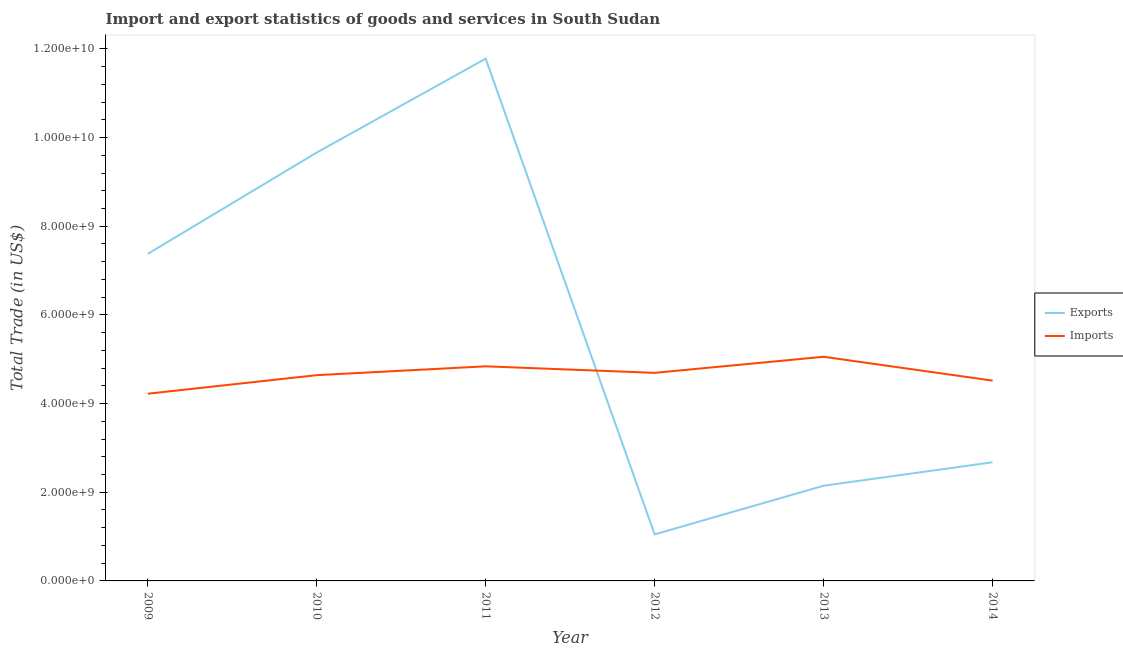Does the line corresponding to export of goods and services intersect with the line corresponding to imports of goods and services?
Give a very brief answer. Yes. What is the export of goods and services in 2010?
Your answer should be compact. 9.66e+09. Across all years, what is the maximum export of goods and services?
Your response must be concise. 1.18e+1. Across all years, what is the minimum imports of goods and services?
Your answer should be very brief. 4.22e+09. What is the total export of goods and services in the graph?
Offer a terse response. 3.47e+1. What is the difference between the export of goods and services in 2012 and that in 2013?
Offer a very short reply. -1.10e+09. What is the difference between the export of goods and services in 2012 and the imports of goods and services in 2014?
Keep it short and to the point. -3.47e+09. What is the average imports of goods and services per year?
Provide a succinct answer. 4.66e+09. In the year 2011, what is the difference between the imports of goods and services and export of goods and services?
Make the answer very short. -6.94e+09. In how many years, is the imports of goods and services greater than 5600000000 US$?
Your answer should be very brief. 0. What is the ratio of the imports of goods and services in 2009 to that in 2011?
Ensure brevity in your answer.  0.87. Is the difference between the export of goods and services in 2009 and 2012 greater than the difference between the imports of goods and services in 2009 and 2012?
Ensure brevity in your answer.  Yes. What is the difference between the highest and the second highest imports of goods and services?
Provide a succinct answer. 2.16e+08. What is the difference between the highest and the lowest imports of goods and services?
Keep it short and to the point. 8.33e+08. Is the sum of the imports of goods and services in 2009 and 2012 greater than the maximum export of goods and services across all years?
Make the answer very short. No. Does the imports of goods and services monotonically increase over the years?
Your answer should be very brief. No. Is the export of goods and services strictly greater than the imports of goods and services over the years?
Offer a very short reply. No. How many lines are there?
Provide a succinct answer. 2. What is the difference between two consecutive major ticks on the Y-axis?
Your response must be concise. 2.00e+09. Are the values on the major ticks of Y-axis written in scientific E-notation?
Give a very brief answer. Yes. Does the graph contain grids?
Provide a succinct answer. No. Where does the legend appear in the graph?
Keep it short and to the point. Center right. What is the title of the graph?
Make the answer very short. Import and export statistics of goods and services in South Sudan. What is the label or title of the Y-axis?
Offer a terse response. Total Trade (in US$). What is the Total Trade (in US$) of Exports in 2009?
Ensure brevity in your answer.  7.38e+09. What is the Total Trade (in US$) of Imports in 2009?
Make the answer very short. 4.22e+09. What is the Total Trade (in US$) in Exports in 2010?
Ensure brevity in your answer.  9.66e+09. What is the Total Trade (in US$) in Imports in 2010?
Your answer should be very brief. 4.64e+09. What is the Total Trade (in US$) in Exports in 2011?
Offer a very short reply. 1.18e+1. What is the Total Trade (in US$) in Imports in 2011?
Offer a terse response. 4.84e+09. What is the Total Trade (in US$) in Exports in 2012?
Give a very brief answer. 1.05e+09. What is the Total Trade (in US$) in Imports in 2012?
Offer a very short reply. 4.69e+09. What is the Total Trade (in US$) of Exports in 2013?
Ensure brevity in your answer.  2.15e+09. What is the Total Trade (in US$) of Imports in 2013?
Your answer should be very brief. 5.06e+09. What is the Total Trade (in US$) in Exports in 2014?
Your answer should be compact. 2.68e+09. What is the Total Trade (in US$) in Imports in 2014?
Keep it short and to the point. 4.52e+09. Across all years, what is the maximum Total Trade (in US$) of Exports?
Your answer should be compact. 1.18e+1. Across all years, what is the maximum Total Trade (in US$) of Imports?
Ensure brevity in your answer.  5.06e+09. Across all years, what is the minimum Total Trade (in US$) of Exports?
Offer a very short reply. 1.05e+09. Across all years, what is the minimum Total Trade (in US$) in Imports?
Your response must be concise. 4.22e+09. What is the total Total Trade (in US$) in Exports in the graph?
Make the answer very short. 3.47e+1. What is the total Total Trade (in US$) of Imports in the graph?
Provide a short and direct response. 2.80e+1. What is the difference between the Total Trade (in US$) of Exports in 2009 and that in 2010?
Your answer should be very brief. -2.28e+09. What is the difference between the Total Trade (in US$) in Imports in 2009 and that in 2010?
Provide a short and direct response. -4.19e+08. What is the difference between the Total Trade (in US$) in Exports in 2009 and that in 2011?
Your response must be concise. -4.40e+09. What is the difference between the Total Trade (in US$) in Imports in 2009 and that in 2011?
Give a very brief answer. -6.18e+08. What is the difference between the Total Trade (in US$) in Exports in 2009 and that in 2012?
Your response must be concise. 6.33e+09. What is the difference between the Total Trade (in US$) in Imports in 2009 and that in 2012?
Offer a terse response. -4.70e+08. What is the difference between the Total Trade (in US$) of Exports in 2009 and that in 2013?
Your response must be concise. 5.23e+09. What is the difference between the Total Trade (in US$) of Imports in 2009 and that in 2013?
Provide a succinct answer. -8.33e+08. What is the difference between the Total Trade (in US$) in Exports in 2009 and that in 2014?
Provide a short and direct response. 4.70e+09. What is the difference between the Total Trade (in US$) of Imports in 2009 and that in 2014?
Your answer should be very brief. -2.95e+08. What is the difference between the Total Trade (in US$) of Exports in 2010 and that in 2011?
Offer a terse response. -2.12e+09. What is the difference between the Total Trade (in US$) of Imports in 2010 and that in 2011?
Your answer should be very brief. -1.99e+08. What is the difference between the Total Trade (in US$) of Exports in 2010 and that in 2012?
Provide a succinct answer. 8.61e+09. What is the difference between the Total Trade (in US$) in Imports in 2010 and that in 2012?
Offer a very short reply. -5.19e+07. What is the difference between the Total Trade (in US$) in Exports in 2010 and that in 2013?
Ensure brevity in your answer.  7.51e+09. What is the difference between the Total Trade (in US$) in Imports in 2010 and that in 2013?
Provide a succinct answer. -4.15e+08. What is the difference between the Total Trade (in US$) of Exports in 2010 and that in 2014?
Make the answer very short. 6.99e+09. What is the difference between the Total Trade (in US$) of Imports in 2010 and that in 2014?
Give a very brief answer. 1.23e+08. What is the difference between the Total Trade (in US$) in Exports in 2011 and that in 2012?
Provide a short and direct response. 1.07e+1. What is the difference between the Total Trade (in US$) in Imports in 2011 and that in 2012?
Give a very brief answer. 1.47e+08. What is the difference between the Total Trade (in US$) in Exports in 2011 and that in 2013?
Ensure brevity in your answer.  9.63e+09. What is the difference between the Total Trade (in US$) of Imports in 2011 and that in 2013?
Keep it short and to the point. -2.16e+08. What is the difference between the Total Trade (in US$) in Exports in 2011 and that in 2014?
Offer a very short reply. 9.10e+09. What is the difference between the Total Trade (in US$) in Imports in 2011 and that in 2014?
Keep it short and to the point. 3.22e+08. What is the difference between the Total Trade (in US$) in Exports in 2012 and that in 2013?
Make the answer very short. -1.10e+09. What is the difference between the Total Trade (in US$) of Imports in 2012 and that in 2013?
Your answer should be very brief. -3.63e+08. What is the difference between the Total Trade (in US$) of Exports in 2012 and that in 2014?
Keep it short and to the point. -1.63e+09. What is the difference between the Total Trade (in US$) of Imports in 2012 and that in 2014?
Provide a succinct answer. 1.75e+08. What is the difference between the Total Trade (in US$) of Exports in 2013 and that in 2014?
Keep it short and to the point. -5.29e+08. What is the difference between the Total Trade (in US$) in Imports in 2013 and that in 2014?
Provide a short and direct response. 5.38e+08. What is the difference between the Total Trade (in US$) in Exports in 2009 and the Total Trade (in US$) in Imports in 2010?
Give a very brief answer. 2.74e+09. What is the difference between the Total Trade (in US$) in Exports in 2009 and the Total Trade (in US$) in Imports in 2011?
Make the answer very short. 2.54e+09. What is the difference between the Total Trade (in US$) of Exports in 2009 and the Total Trade (in US$) of Imports in 2012?
Make the answer very short. 2.68e+09. What is the difference between the Total Trade (in US$) of Exports in 2009 and the Total Trade (in US$) of Imports in 2013?
Offer a terse response. 2.32e+09. What is the difference between the Total Trade (in US$) of Exports in 2009 and the Total Trade (in US$) of Imports in 2014?
Offer a very short reply. 2.86e+09. What is the difference between the Total Trade (in US$) of Exports in 2010 and the Total Trade (in US$) of Imports in 2011?
Give a very brief answer. 4.82e+09. What is the difference between the Total Trade (in US$) in Exports in 2010 and the Total Trade (in US$) in Imports in 2012?
Make the answer very short. 4.97e+09. What is the difference between the Total Trade (in US$) of Exports in 2010 and the Total Trade (in US$) of Imports in 2013?
Your response must be concise. 4.61e+09. What is the difference between the Total Trade (in US$) in Exports in 2010 and the Total Trade (in US$) in Imports in 2014?
Offer a terse response. 5.14e+09. What is the difference between the Total Trade (in US$) of Exports in 2011 and the Total Trade (in US$) of Imports in 2012?
Your answer should be compact. 7.09e+09. What is the difference between the Total Trade (in US$) in Exports in 2011 and the Total Trade (in US$) in Imports in 2013?
Make the answer very short. 6.72e+09. What is the difference between the Total Trade (in US$) in Exports in 2011 and the Total Trade (in US$) in Imports in 2014?
Ensure brevity in your answer.  7.26e+09. What is the difference between the Total Trade (in US$) in Exports in 2012 and the Total Trade (in US$) in Imports in 2013?
Offer a terse response. -4.01e+09. What is the difference between the Total Trade (in US$) of Exports in 2012 and the Total Trade (in US$) of Imports in 2014?
Ensure brevity in your answer.  -3.47e+09. What is the difference between the Total Trade (in US$) in Exports in 2013 and the Total Trade (in US$) in Imports in 2014?
Your answer should be very brief. -2.37e+09. What is the average Total Trade (in US$) in Exports per year?
Your answer should be compact. 5.78e+09. What is the average Total Trade (in US$) of Imports per year?
Offer a very short reply. 4.66e+09. In the year 2009, what is the difference between the Total Trade (in US$) of Exports and Total Trade (in US$) of Imports?
Provide a succinct answer. 3.15e+09. In the year 2010, what is the difference between the Total Trade (in US$) in Exports and Total Trade (in US$) in Imports?
Your answer should be compact. 5.02e+09. In the year 2011, what is the difference between the Total Trade (in US$) of Exports and Total Trade (in US$) of Imports?
Your answer should be very brief. 6.94e+09. In the year 2012, what is the difference between the Total Trade (in US$) in Exports and Total Trade (in US$) in Imports?
Offer a terse response. -3.64e+09. In the year 2013, what is the difference between the Total Trade (in US$) of Exports and Total Trade (in US$) of Imports?
Provide a succinct answer. -2.91e+09. In the year 2014, what is the difference between the Total Trade (in US$) of Exports and Total Trade (in US$) of Imports?
Your response must be concise. -1.84e+09. What is the ratio of the Total Trade (in US$) in Exports in 2009 to that in 2010?
Your answer should be compact. 0.76. What is the ratio of the Total Trade (in US$) in Imports in 2009 to that in 2010?
Provide a short and direct response. 0.91. What is the ratio of the Total Trade (in US$) in Exports in 2009 to that in 2011?
Your response must be concise. 0.63. What is the ratio of the Total Trade (in US$) of Imports in 2009 to that in 2011?
Your answer should be compact. 0.87. What is the ratio of the Total Trade (in US$) of Exports in 2009 to that in 2012?
Give a very brief answer. 7.03. What is the ratio of the Total Trade (in US$) of Imports in 2009 to that in 2012?
Make the answer very short. 0.9. What is the ratio of the Total Trade (in US$) of Exports in 2009 to that in 2013?
Keep it short and to the point. 3.44. What is the ratio of the Total Trade (in US$) in Imports in 2009 to that in 2013?
Your response must be concise. 0.84. What is the ratio of the Total Trade (in US$) of Exports in 2009 to that in 2014?
Make the answer very short. 2.76. What is the ratio of the Total Trade (in US$) of Imports in 2009 to that in 2014?
Make the answer very short. 0.93. What is the ratio of the Total Trade (in US$) of Exports in 2010 to that in 2011?
Offer a very short reply. 0.82. What is the ratio of the Total Trade (in US$) of Imports in 2010 to that in 2011?
Offer a terse response. 0.96. What is the ratio of the Total Trade (in US$) in Exports in 2010 to that in 2012?
Keep it short and to the point. 9.21. What is the ratio of the Total Trade (in US$) of Imports in 2010 to that in 2012?
Offer a very short reply. 0.99. What is the ratio of the Total Trade (in US$) in Imports in 2010 to that in 2013?
Give a very brief answer. 0.92. What is the ratio of the Total Trade (in US$) of Exports in 2010 to that in 2014?
Your answer should be very brief. 3.61. What is the ratio of the Total Trade (in US$) of Imports in 2010 to that in 2014?
Provide a short and direct response. 1.03. What is the ratio of the Total Trade (in US$) of Exports in 2011 to that in 2012?
Offer a terse response. 11.22. What is the ratio of the Total Trade (in US$) in Imports in 2011 to that in 2012?
Give a very brief answer. 1.03. What is the ratio of the Total Trade (in US$) in Exports in 2011 to that in 2013?
Offer a very short reply. 5.49. What is the ratio of the Total Trade (in US$) in Imports in 2011 to that in 2013?
Provide a succinct answer. 0.96. What is the ratio of the Total Trade (in US$) of Exports in 2011 to that in 2014?
Provide a succinct answer. 4.4. What is the ratio of the Total Trade (in US$) of Imports in 2011 to that in 2014?
Keep it short and to the point. 1.07. What is the ratio of the Total Trade (in US$) in Exports in 2012 to that in 2013?
Make the answer very short. 0.49. What is the ratio of the Total Trade (in US$) of Imports in 2012 to that in 2013?
Your answer should be compact. 0.93. What is the ratio of the Total Trade (in US$) of Exports in 2012 to that in 2014?
Ensure brevity in your answer.  0.39. What is the ratio of the Total Trade (in US$) in Imports in 2012 to that in 2014?
Provide a succinct answer. 1.04. What is the ratio of the Total Trade (in US$) of Exports in 2013 to that in 2014?
Your response must be concise. 0.8. What is the ratio of the Total Trade (in US$) of Imports in 2013 to that in 2014?
Your answer should be compact. 1.12. What is the difference between the highest and the second highest Total Trade (in US$) in Exports?
Keep it short and to the point. 2.12e+09. What is the difference between the highest and the second highest Total Trade (in US$) in Imports?
Your answer should be very brief. 2.16e+08. What is the difference between the highest and the lowest Total Trade (in US$) of Exports?
Offer a terse response. 1.07e+1. What is the difference between the highest and the lowest Total Trade (in US$) of Imports?
Provide a short and direct response. 8.33e+08. 